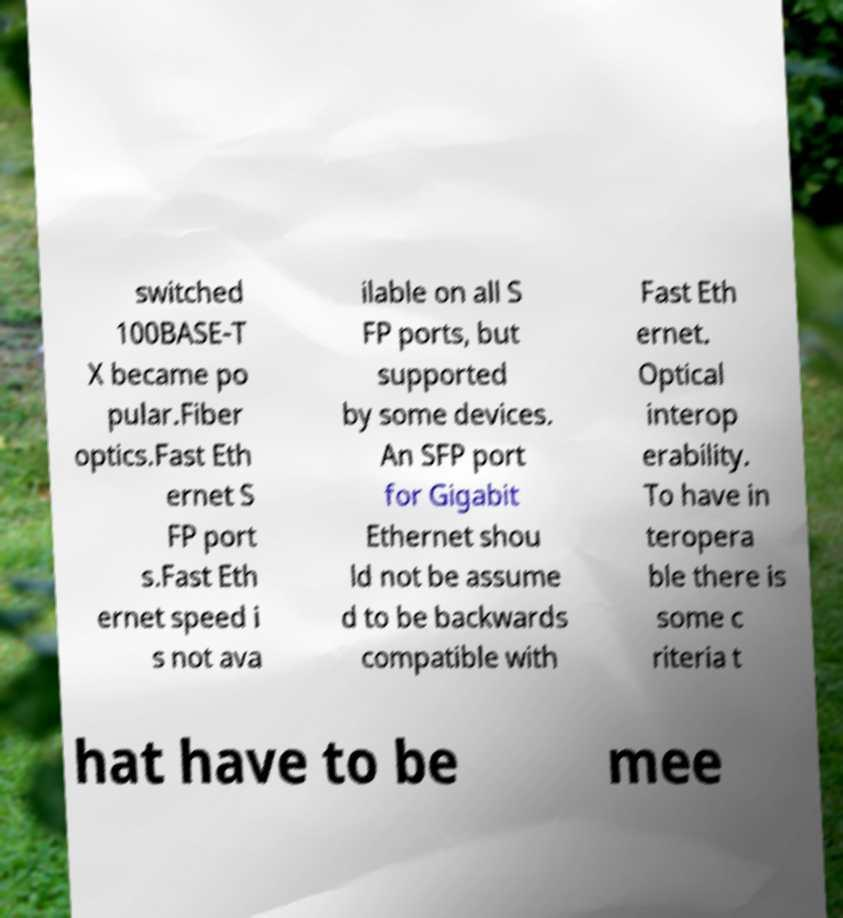For documentation purposes, I need the text within this image transcribed. Could you provide that? switched 100BASE-T X became po pular.Fiber optics.Fast Eth ernet S FP port s.Fast Eth ernet speed i s not ava ilable on all S FP ports, but supported by some devices. An SFP port for Gigabit Ethernet shou ld not be assume d to be backwards compatible with Fast Eth ernet. Optical interop erability. To have in teropera ble there is some c riteria t hat have to be mee 